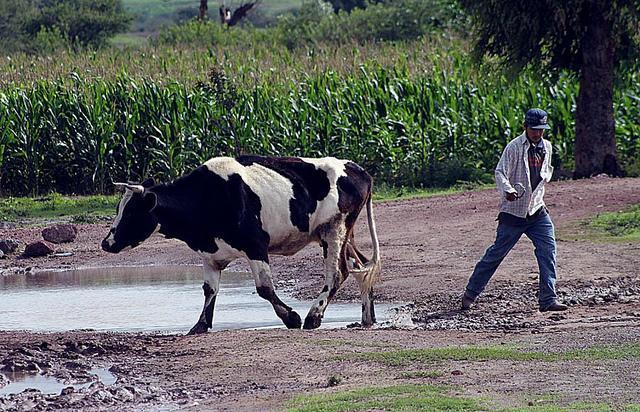How many baby elephants are there?
Give a very brief answer. 0. 